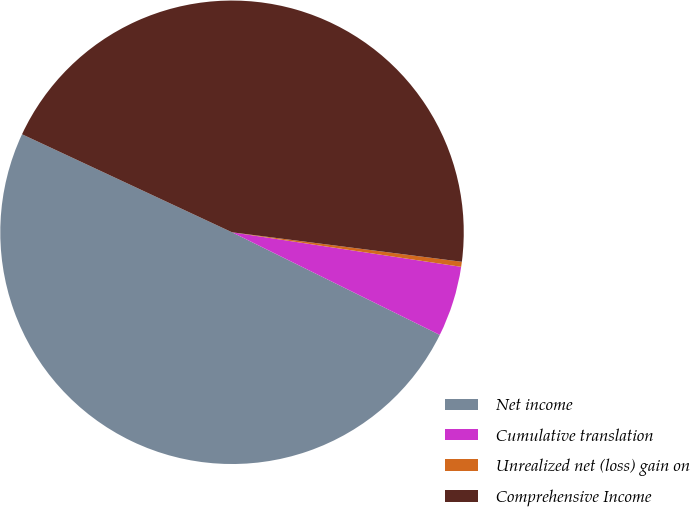<chart> <loc_0><loc_0><loc_500><loc_500><pie_chart><fcel>Net income<fcel>Cumulative translation<fcel>Unrealized net (loss) gain on<fcel>Comprehensive Income<nl><fcel>49.65%<fcel>4.92%<fcel>0.35%<fcel>45.08%<nl></chart> 